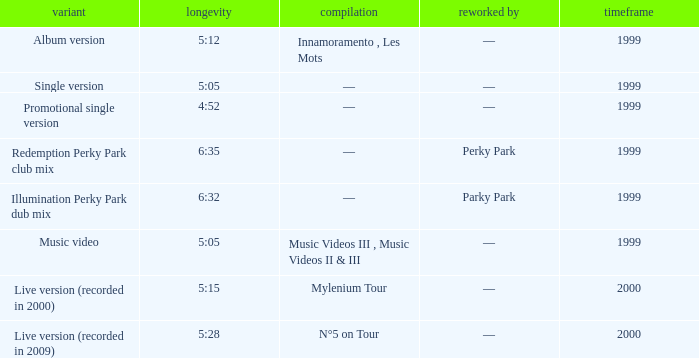What album is 5:15 long Live version (recorded in 2000). 